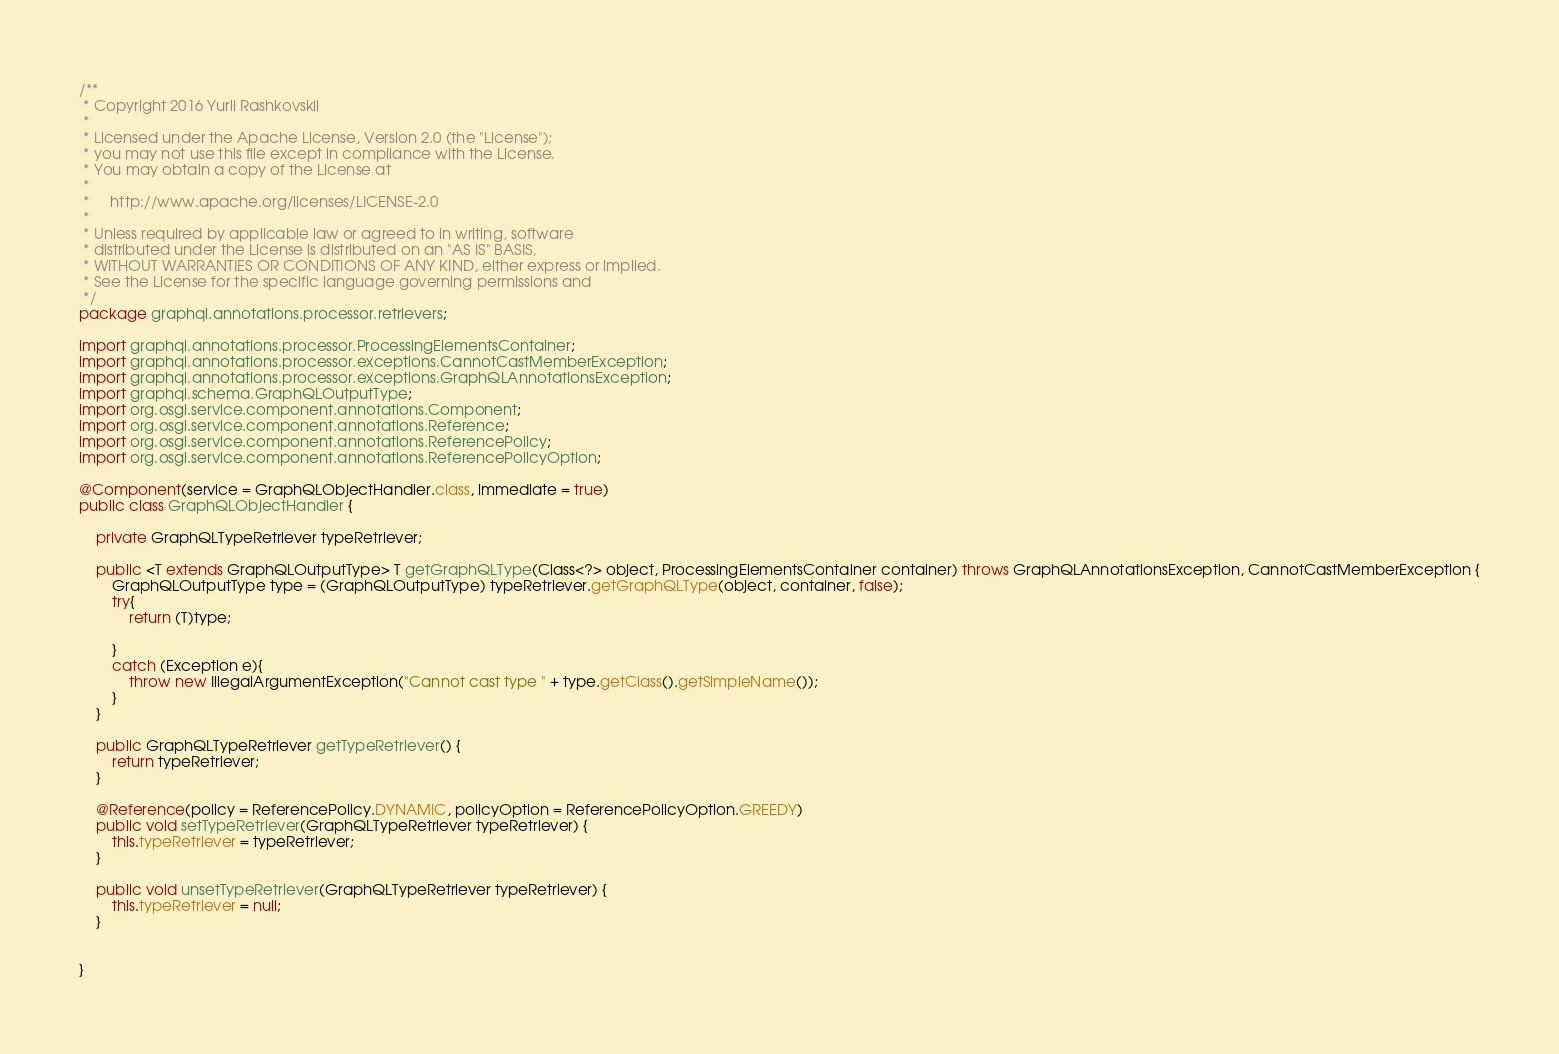Convert code to text. <code><loc_0><loc_0><loc_500><loc_500><_Java_>/**
 * Copyright 2016 Yurii Rashkovskii
 *
 * Licensed under the Apache License, Version 2.0 (the "License");
 * you may not use this file except in compliance with the License.
 * You may obtain a copy of the License at
 *
 *     http://www.apache.org/licenses/LICENSE-2.0
 *
 * Unless required by applicable law or agreed to in writing, software
 * distributed under the License is distributed on an "AS IS" BASIS,
 * WITHOUT WARRANTIES OR CONDITIONS OF ANY KIND, either express or implied.
 * See the License for the specific language governing permissions and
 */
package graphql.annotations.processor.retrievers;

import graphql.annotations.processor.ProcessingElementsContainer;
import graphql.annotations.processor.exceptions.CannotCastMemberException;
import graphql.annotations.processor.exceptions.GraphQLAnnotationsException;
import graphql.schema.GraphQLOutputType;
import org.osgi.service.component.annotations.Component;
import org.osgi.service.component.annotations.Reference;
import org.osgi.service.component.annotations.ReferencePolicy;
import org.osgi.service.component.annotations.ReferencePolicyOption;

@Component(service = GraphQLObjectHandler.class, immediate = true)
public class GraphQLObjectHandler {

    private GraphQLTypeRetriever typeRetriever;

    public <T extends GraphQLOutputType> T getGraphQLType(Class<?> object, ProcessingElementsContainer container) throws GraphQLAnnotationsException, CannotCastMemberException {
        GraphQLOutputType type = (GraphQLOutputType) typeRetriever.getGraphQLType(object, container, false);
        try{
            return (T)type;

        }
        catch (Exception e){
            throw new IllegalArgumentException("Cannot cast type " + type.getClass().getSimpleName());
        }
    }

    public GraphQLTypeRetriever getTypeRetriever() {
        return typeRetriever;
    }

    @Reference(policy = ReferencePolicy.DYNAMIC, policyOption = ReferencePolicyOption.GREEDY)
    public void setTypeRetriever(GraphQLTypeRetriever typeRetriever) {
        this.typeRetriever = typeRetriever;
    }

    public void unsetTypeRetriever(GraphQLTypeRetriever typeRetriever) {
        this.typeRetriever = null;
    }


}
</code> 